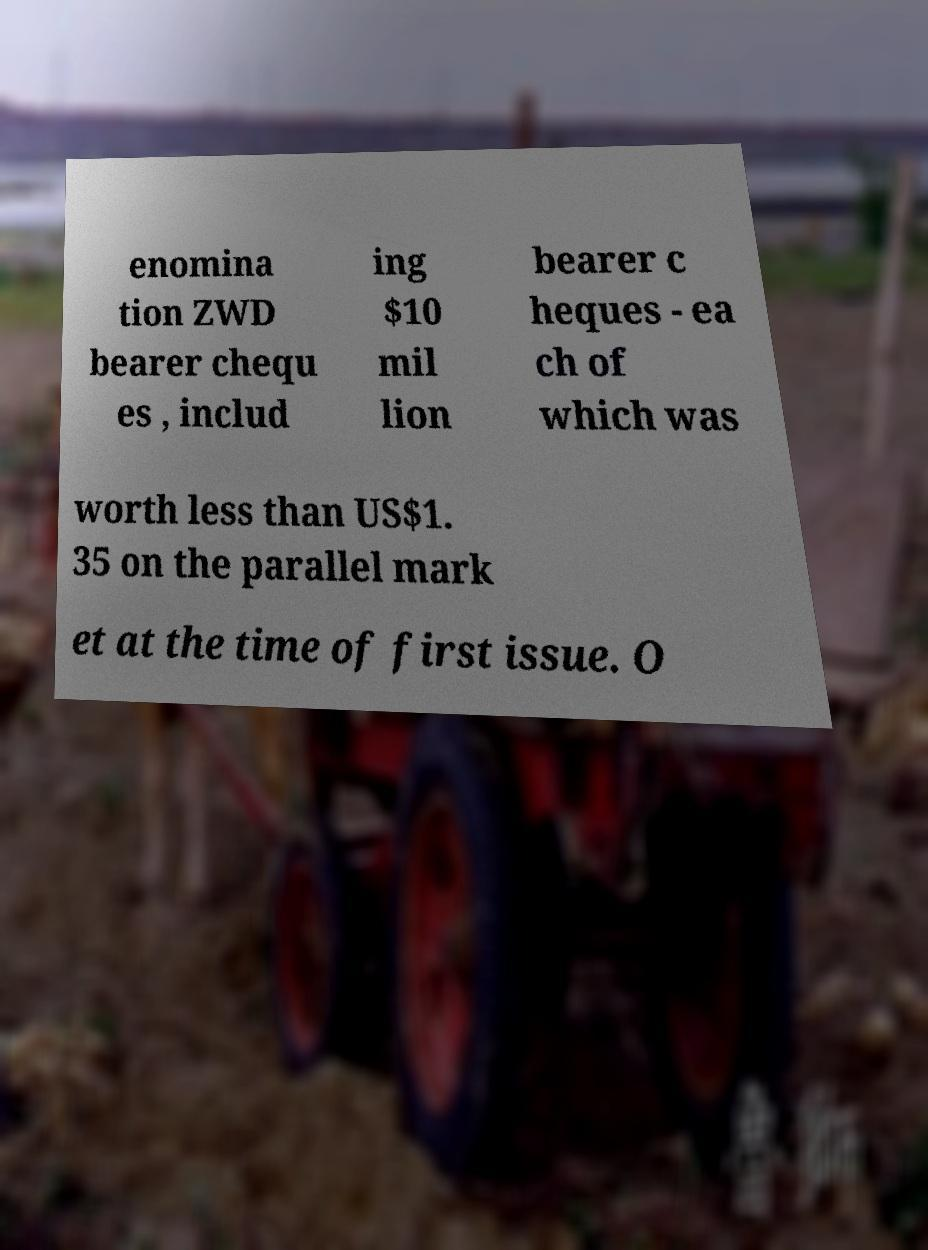Can you read and provide the text displayed in the image?This photo seems to have some interesting text. Can you extract and type it out for me? enomina tion ZWD bearer chequ es , includ ing $10 mil lion bearer c heques - ea ch of which was worth less than US$1. 35 on the parallel mark et at the time of first issue. O 